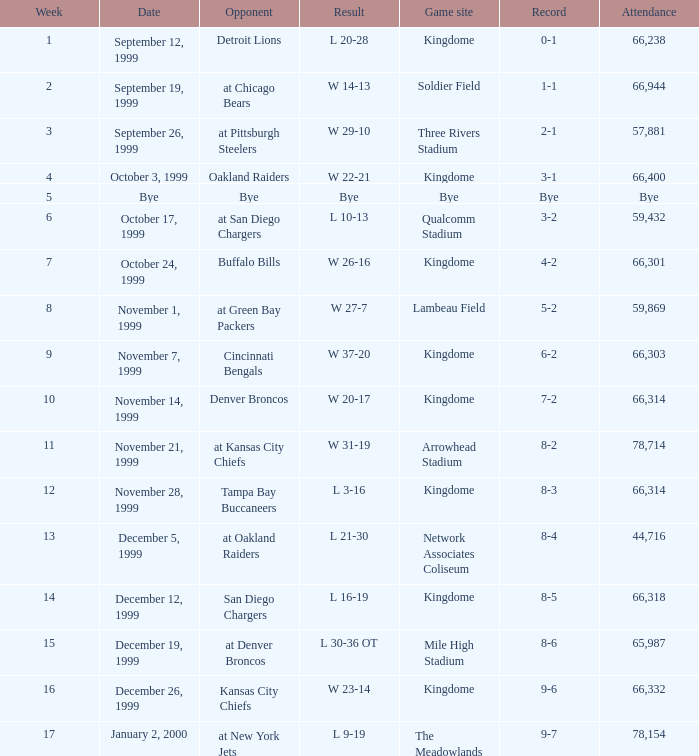What was the result of the game that was played on week 15? L 30-36 OT. 